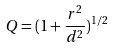Convert formula to latex. <formula><loc_0><loc_0><loc_500><loc_500>Q = ( 1 + \frac { r ^ { 2 } } { d ^ { 2 } } ) ^ { 1 / 2 }</formula> 